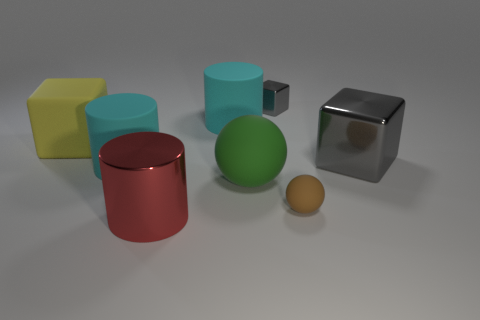Subtract all tiny blocks. How many blocks are left? 2 Subtract all green cylinders. How many gray cubes are left? 2 Add 1 yellow rubber objects. How many objects exist? 9 Subtract all brown balls. How many balls are left? 1 Subtract all cylinders. How many objects are left? 5 Subtract 3 cubes. How many cubes are left? 0 Subtract 0 cyan cubes. How many objects are left? 8 Subtract all yellow cylinders. Subtract all gray blocks. How many cylinders are left? 3 Subtract all blue objects. Subtract all yellow blocks. How many objects are left? 7 Add 5 large metallic objects. How many large metallic objects are left? 7 